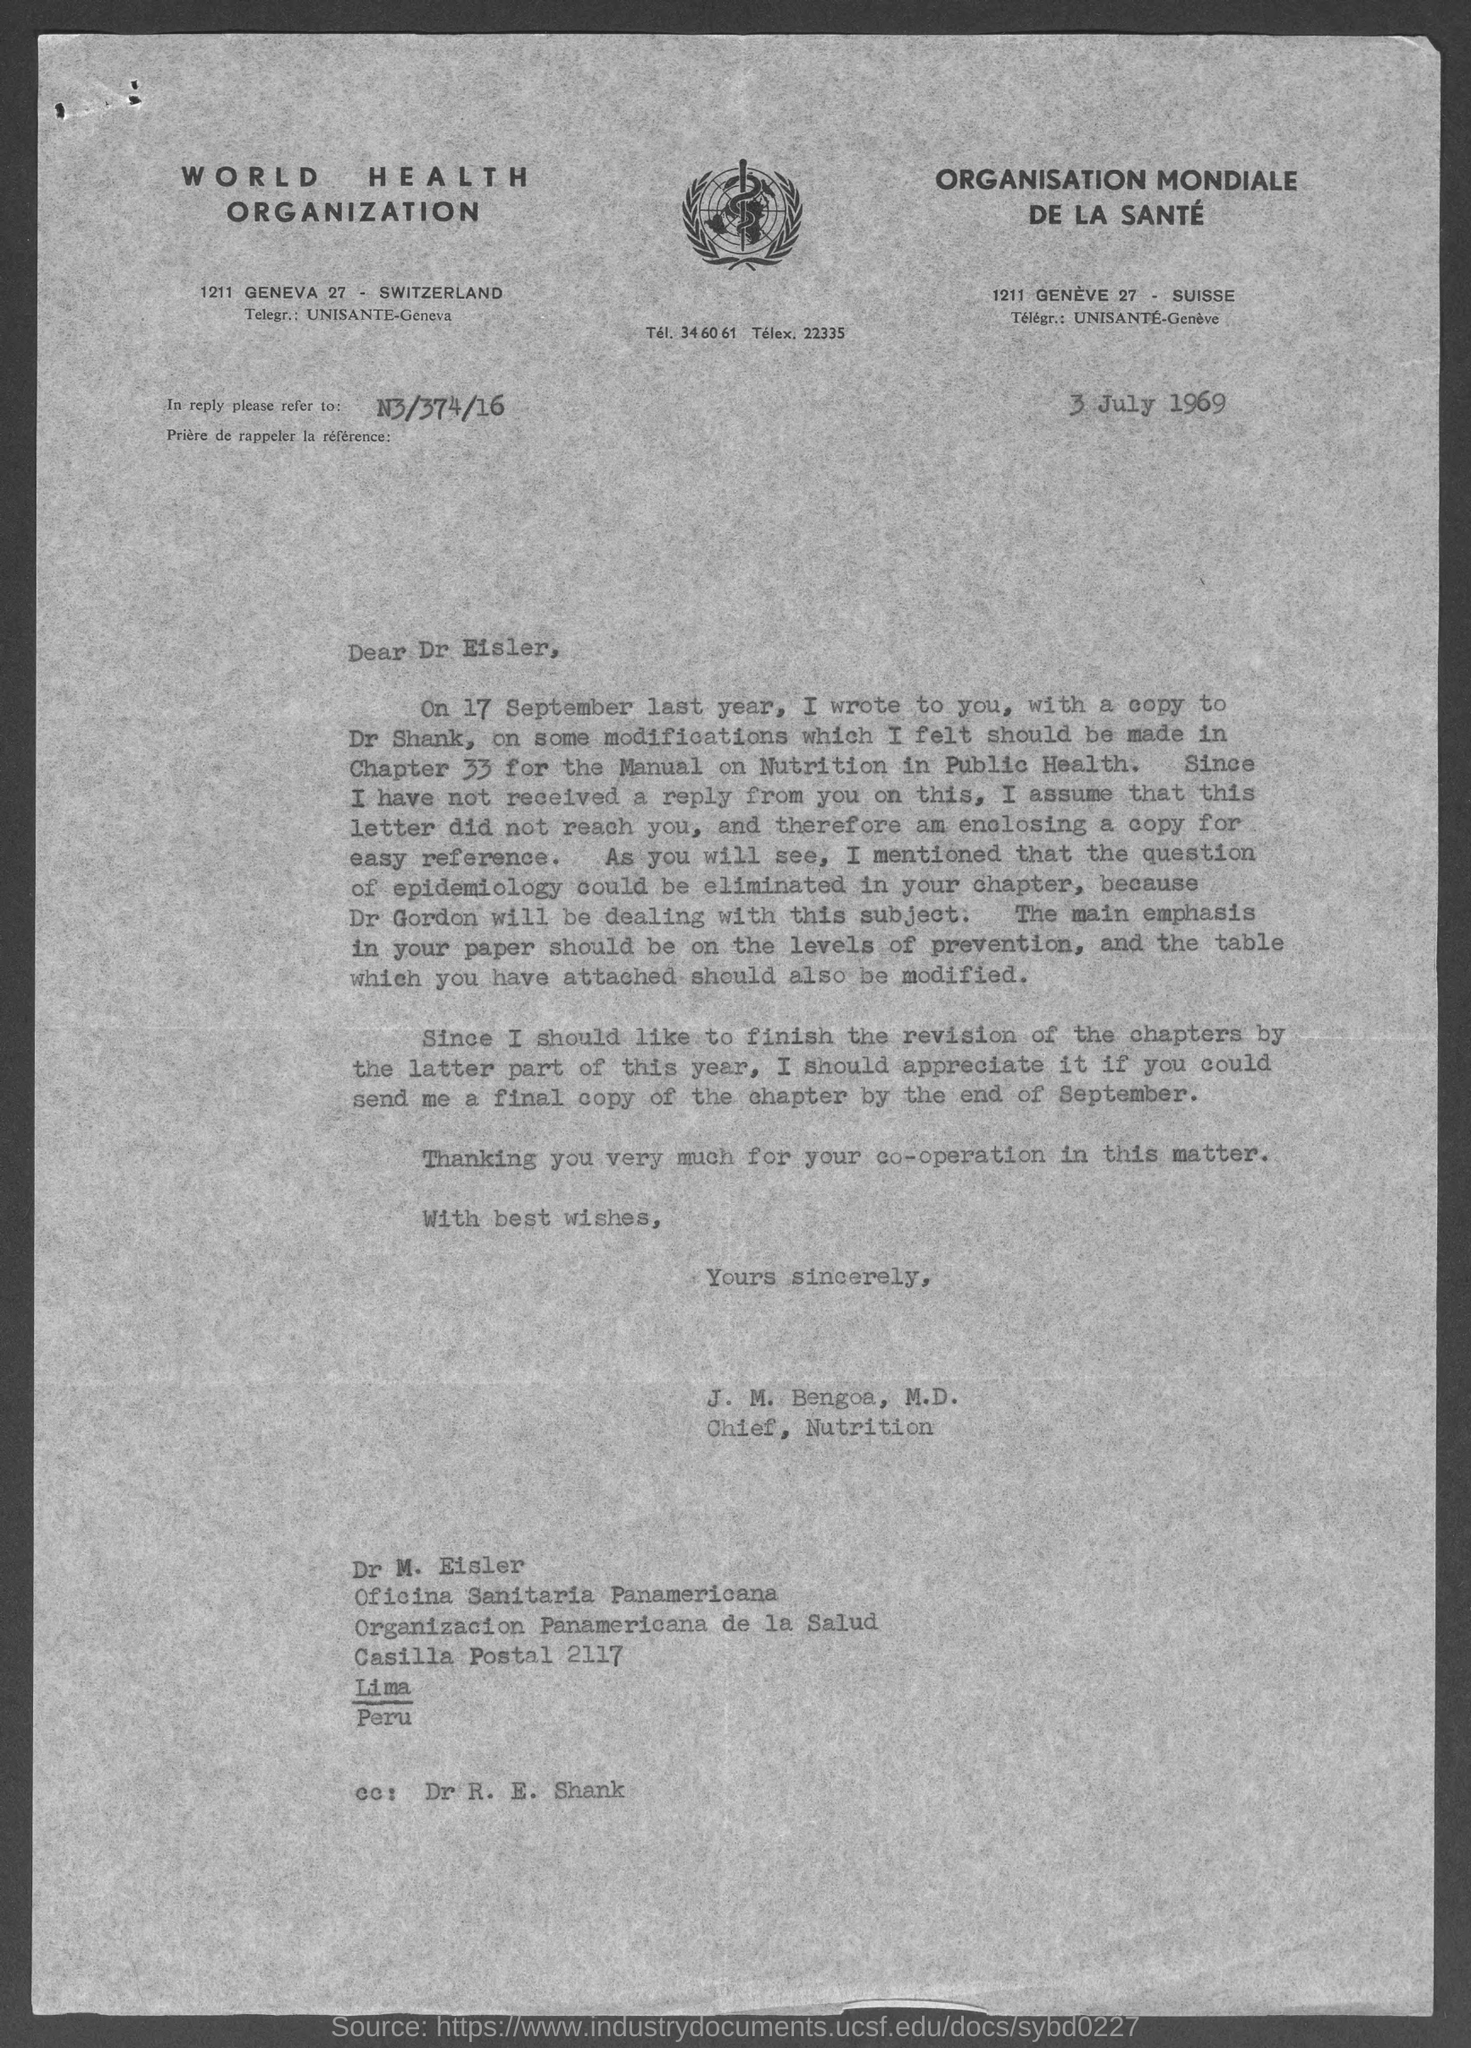What is the address of world health organisation ?
Provide a succinct answer. 1211 Geneva 27- Switzerland. What is the postal code of casilla ?
Offer a terse response. 2117. To whom this letter is written to?
Provide a succinct answer. DR. EISLER. 